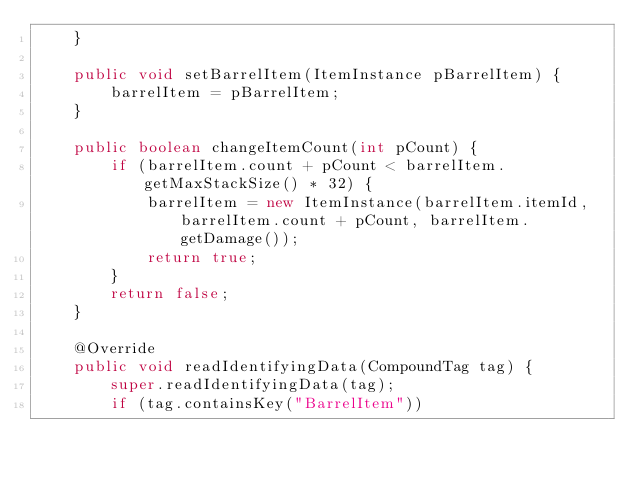Convert code to text. <code><loc_0><loc_0><loc_500><loc_500><_Java_>    }

    public void setBarrelItem(ItemInstance pBarrelItem) {
        barrelItem = pBarrelItem;
    }

    public boolean changeItemCount(int pCount) {
        if (barrelItem.count + pCount < barrelItem.getMaxStackSize() * 32) {
            barrelItem = new ItemInstance(barrelItem.itemId, barrelItem.count + pCount, barrelItem.getDamage());
            return true;
        }
        return false;
    }

    @Override
    public void readIdentifyingData(CompoundTag tag) {
        super.readIdentifyingData(tag);
        if (tag.containsKey("BarrelItem"))</code> 